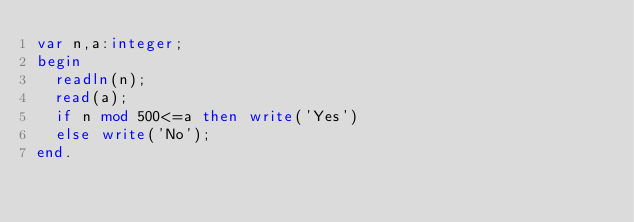Convert code to text. <code><loc_0><loc_0><loc_500><loc_500><_Pascal_>var n,a:integer;
begin
  readln(n);
  read(a);
  if n mod 500<=a then write('Yes')
  else write('No');
end.</code> 